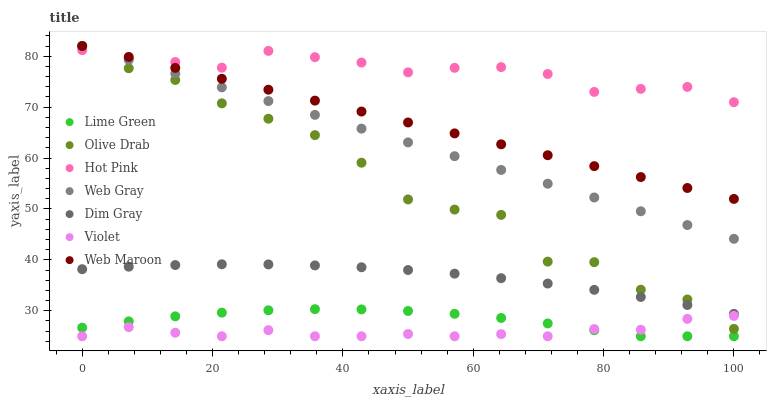Does Violet have the minimum area under the curve?
Answer yes or no. Yes. Does Hot Pink have the maximum area under the curve?
Answer yes or no. Yes. Does Web Maroon have the minimum area under the curve?
Answer yes or no. No. Does Web Maroon have the maximum area under the curve?
Answer yes or no. No. Is Web Maroon the smoothest?
Answer yes or no. Yes. Is Olive Drab the roughest?
Answer yes or no. Yes. Is Hot Pink the smoothest?
Answer yes or no. No. Is Hot Pink the roughest?
Answer yes or no. No. Does Violet have the lowest value?
Answer yes or no. Yes. Does Web Maroon have the lowest value?
Answer yes or no. No. Does Olive Drab have the highest value?
Answer yes or no. Yes. Does Hot Pink have the highest value?
Answer yes or no. No. Is Violet less than Dim Gray?
Answer yes or no. Yes. Is Web Gray greater than Lime Green?
Answer yes or no. Yes. Does Lime Green intersect Violet?
Answer yes or no. Yes. Is Lime Green less than Violet?
Answer yes or no. No. Is Lime Green greater than Violet?
Answer yes or no. No. Does Violet intersect Dim Gray?
Answer yes or no. No. 